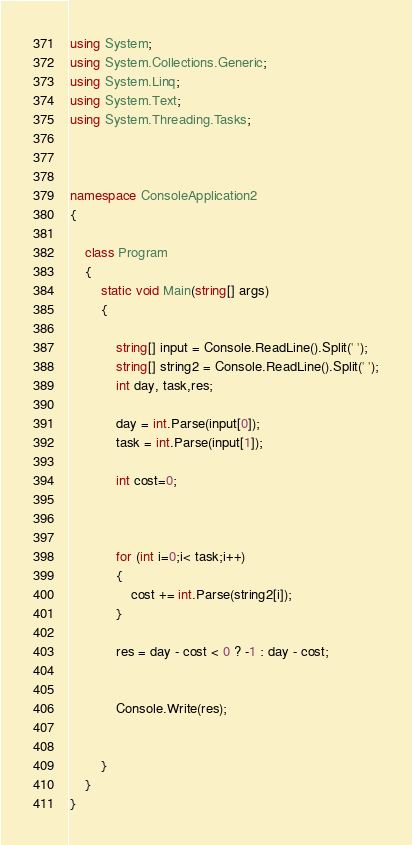<code> <loc_0><loc_0><loc_500><loc_500><_C#_>using System;
using System.Collections.Generic;
using System.Linq;
using System.Text;
using System.Threading.Tasks;



namespace ConsoleApplication2
{

    class Program
    {
        static void Main(string[] args)
        {

            string[] input = Console.ReadLine().Split(' ');
            string[] string2 = Console.ReadLine().Split(' ');
            int day, task,res;

            day = int.Parse(input[0]);
            task = int.Parse(input[1]);

            int cost=0;



            for (int i=0;i< task;i++)
            {
                cost += int.Parse(string2[i]);
            }

            res = day - cost < 0 ? -1 : day - cost;

  
            Console.Write(res);


        }
    }
}
</code> 